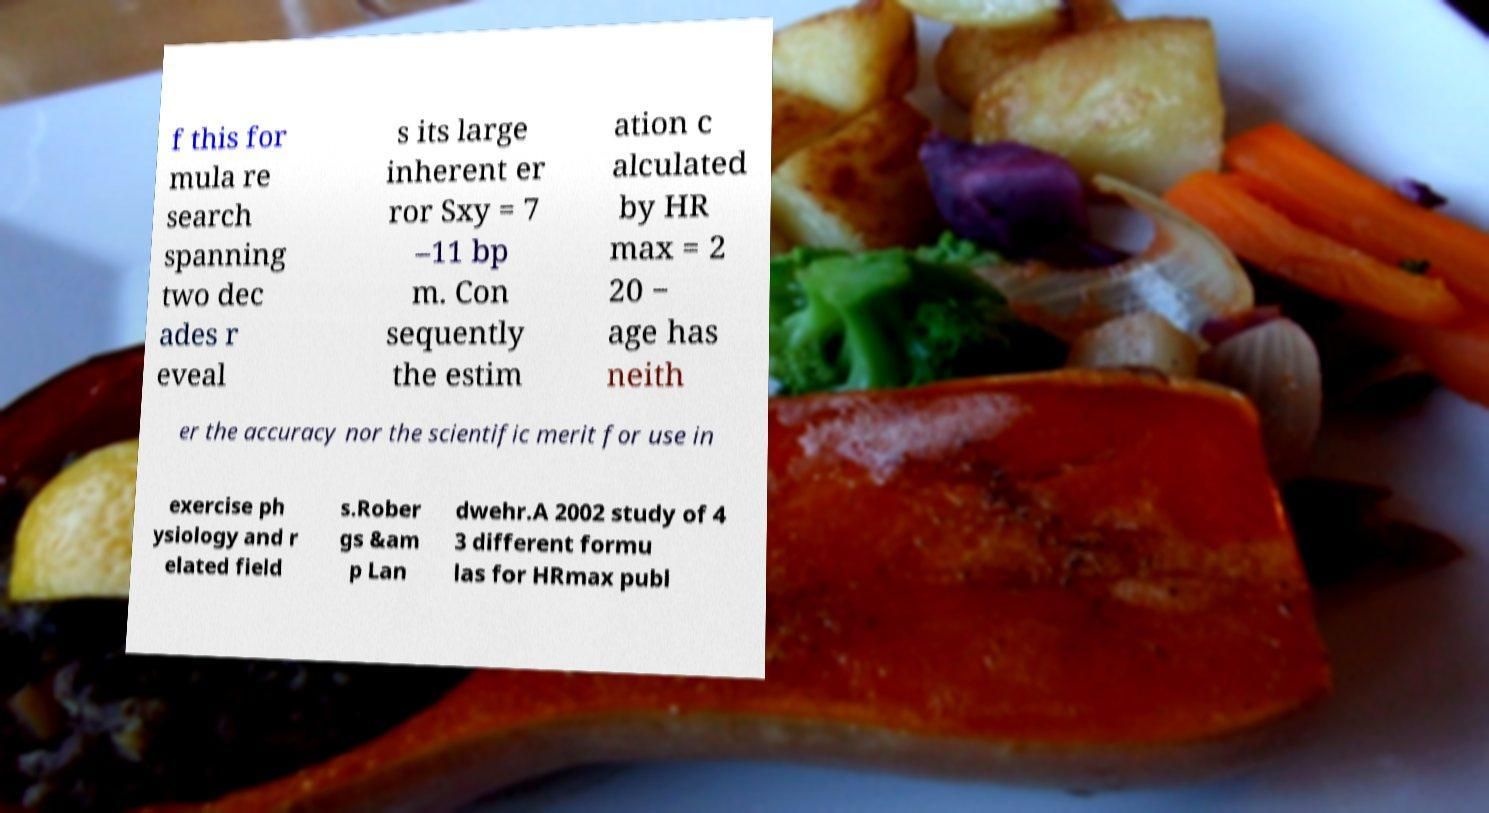I need the written content from this picture converted into text. Can you do that? f this for mula re search spanning two dec ades r eveal s its large inherent er ror Sxy = 7 –11 bp m. Con sequently the estim ation c alculated by HR max = 2 20 − age has neith er the accuracy nor the scientific merit for use in exercise ph ysiology and r elated field s.Rober gs &am p Lan dwehr.A 2002 study of 4 3 different formu las for HRmax publ 